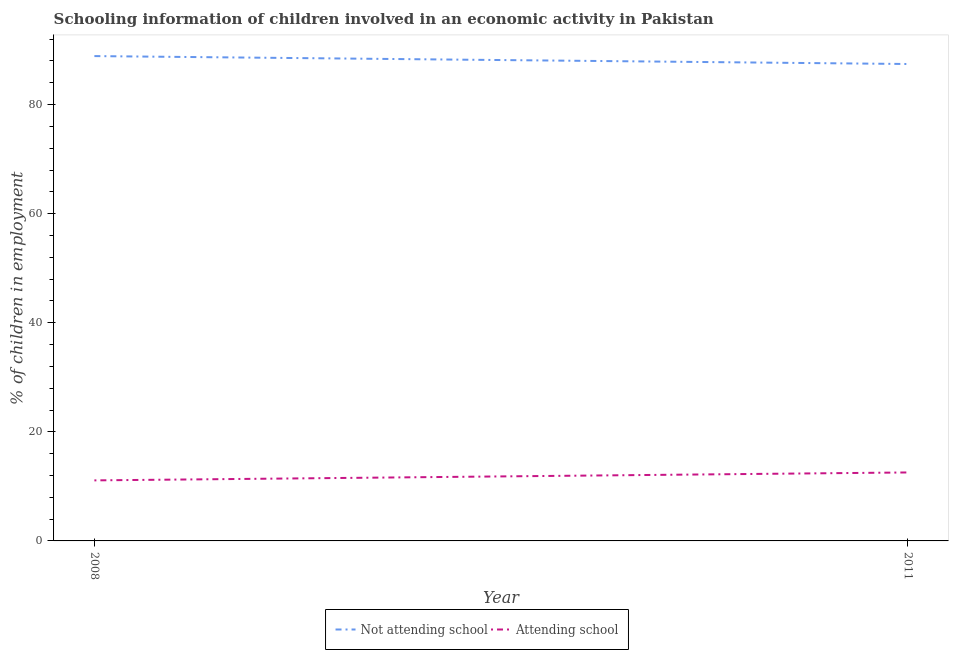How many different coloured lines are there?
Your answer should be compact. 2. Does the line corresponding to percentage of employed children who are attending school intersect with the line corresponding to percentage of employed children who are not attending school?
Offer a terse response. No. What is the percentage of employed children who are attending school in 2008?
Give a very brief answer. 11.1. Across all years, what is the maximum percentage of employed children who are attending school?
Your response must be concise. 12.55. Across all years, what is the minimum percentage of employed children who are attending school?
Give a very brief answer. 11.1. What is the total percentage of employed children who are not attending school in the graph?
Your answer should be very brief. 176.35. What is the difference between the percentage of employed children who are attending school in 2008 and that in 2011?
Your answer should be very brief. -1.45. What is the difference between the percentage of employed children who are attending school in 2011 and the percentage of employed children who are not attending school in 2008?
Your answer should be very brief. -76.35. What is the average percentage of employed children who are attending school per year?
Give a very brief answer. 11.83. In the year 2011, what is the difference between the percentage of employed children who are not attending school and percentage of employed children who are attending school?
Make the answer very short. 74.89. What is the ratio of the percentage of employed children who are attending school in 2008 to that in 2011?
Keep it short and to the point. 0.88. Is the percentage of employed children who are attending school in 2008 less than that in 2011?
Provide a short and direct response. Yes. Does the percentage of employed children who are not attending school monotonically increase over the years?
Make the answer very short. No. Is the percentage of employed children who are not attending school strictly greater than the percentage of employed children who are attending school over the years?
Your response must be concise. Yes. What is the difference between two consecutive major ticks on the Y-axis?
Provide a short and direct response. 20. Are the values on the major ticks of Y-axis written in scientific E-notation?
Make the answer very short. No. Does the graph contain any zero values?
Ensure brevity in your answer.  No. How are the legend labels stacked?
Keep it short and to the point. Horizontal. What is the title of the graph?
Provide a succinct answer. Schooling information of children involved in an economic activity in Pakistan. Does "Domestic Liabilities" appear as one of the legend labels in the graph?
Your response must be concise. No. What is the label or title of the X-axis?
Your answer should be compact. Year. What is the label or title of the Y-axis?
Ensure brevity in your answer.  % of children in employment. What is the % of children in employment in Not attending school in 2008?
Make the answer very short. 88.9. What is the % of children in employment in Attending school in 2008?
Keep it short and to the point. 11.1. What is the % of children in employment of Not attending school in 2011?
Keep it short and to the point. 87.45. What is the % of children in employment in Attending school in 2011?
Provide a succinct answer. 12.55. Across all years, what is the maximum % of children in employment in Not attending school?
Offer a very short reply. 88.9. Across all years, what is the maximum % of children in employment of Attending school?
Offer a very short reply. 12.55. Across all years, what is the minimum % of children in employment of Not attending school?
Keep it short and to the point. 87.45. Across all years, what is the minimum % of children in employment of Attending school?
Make the answer very short. 11.1. What is the total % of children in employment of Not attending school in the graph?
Your answer should be very brief. 176.35. What is the total % of children in employment in Attending school in the graph?
Ensure brevity in your answer.  23.65. What is the difference between the % of children in employment of Not attending school in 2008 and that in 2011?
Ensure brevity in your answer.  1.45. What is the difference between the % of children in employment in Attending school in 2008 and that in 2011?
Keep it short and to the point. -1.45. What is the difference between the % of children in employment in Not attending school in 2008 and the % of children in employment in Attending school in 2011?
Keep it short and to the point. 76.35. What is the average % of children in employment of Not attending school per year?
Your answer should be very brief. 88.17. What is the average % of children in employment of Attending school per year?
Offer a terse response. 11.83. In the year 2008, what is the difference between the % of children in employment in Not attending school and % of children in employment in Attending school?
Offer a terse response. 77.8. In the year 2011, what is the difference between the % of children in employment of Not attending school and % of children in employment of Attending school?
Your response must be concise. 74.89. What is the ratio of the % of children in employment in Not attending school in 2008 to that in 2011?
Provide a succinct answer. 1.02. What is the ratio of the % of children in employment of Attending school in 2008 to that in 2011?
Offer a very short reply. 0.88. What is the difference between the highest and the second highest % of children in employment in Not attending school?
Your answer should be very brief. 1.45. What is the difference between the highest and the second highest % of children in employment in Attending school?
Offer a terse response. 1.45. What is the difference between the highest and the lowest % of children in employment in Not attending school?
Give a very brief answer. 1.45. What is the difference between the highest and the lowest % of children in employment in Attending school?
Your answer should be very brief. 1.45. 